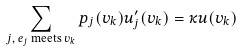<formula> <loc_0><loc_0><loc_500><loc_500>\sum _ { \text {$j$, $e_{j}$ meets $v_{k}$} } p _ { j } ( v _ { k } ) u _ { j } ^ { \prime } ( v _ { k } ) = \kappa u ( v _ { k } )</formula> 